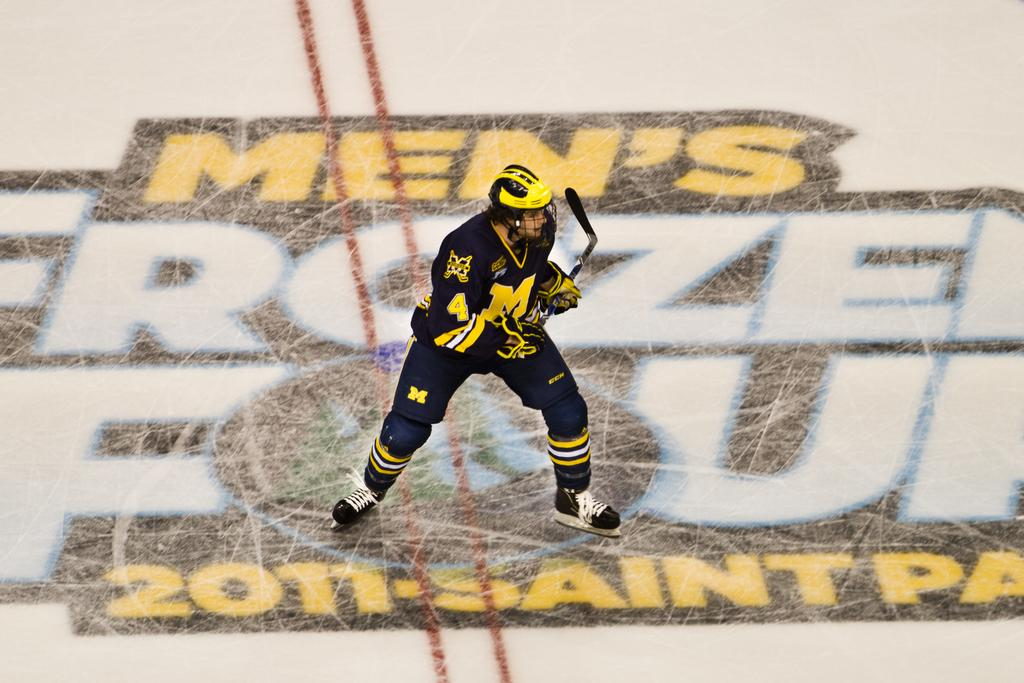Who or what is the main subject in the image? There is a person in the image. What is the person holding in the image? The person is holding a hockey bat. What type of surface is the person standing on? The person is standing on ice. Are there any markings on the ice? Yes, there are letters and numbers written on the ice. What type of tin can be seen in the image? There is no tin present in the image. Can you describe the town where the person is standing in the image? The image does not provide any information about the town or location where the person is standing. 